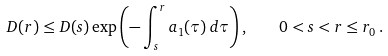<formula> <loc_0><loc_0><loc_500><loc_500>D ( r ) \leq D ( s ) \exp \left ( - \int _ { s } ^ { r } a _ { 1 } ( \tau ) \, d \tau \right ) , \quad 0 < s < r \leq r _ { 0 } \, .</formula> 